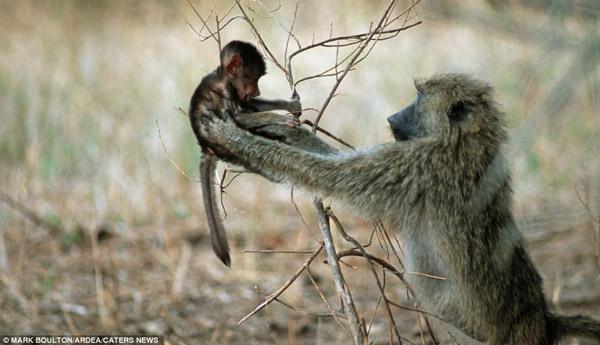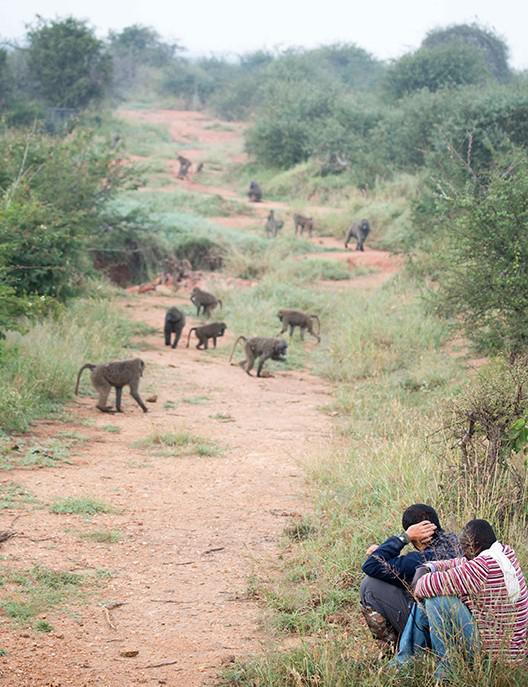The first image is the image on the left, the second image is the image on the right. For the images displayed, is the sentence "There are at most 3 baboons in the left image." factually correct? Answer yes or no. Yes. The first image is the image on the left, the second image is the image on the right. Considering the images on both sides, is "Baboons are walking along a dirt path flanked by bushes and trees in one image." valid? Answer yes or no. Yes. 